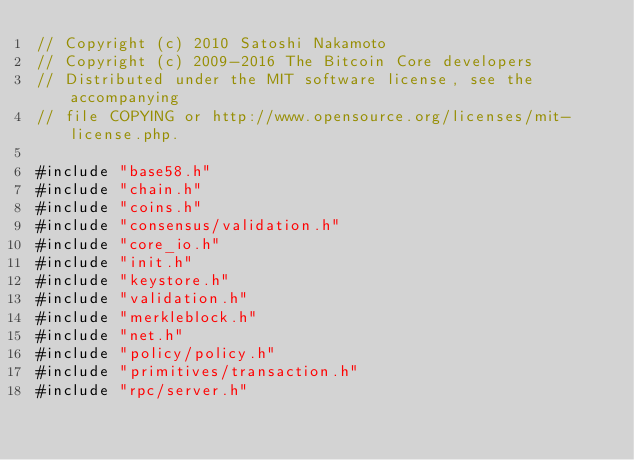Convert code to text. <code><loc_0><loc_0><loc_500><loc_500><_C++_>// Copyright (c) 2010 Satoshi Nakamoto
// Copyright (c) 2009-2016 The Bitcoin Core developers
// Distributed under the MIT software license, see the accompanying
// file COPYING or http://www.opensource.org/licenses/mit-license.php.

#include "base58.h"
#include "chain.h"
#include "coins.h"
#include "consensus/validation.h"
#include "core_io.h"
#include "init.h"
#include "keystore.h"
#include "validation.h"
#include "merkleblock.h"
#include "net.h"
#include "policy/policy.h"
#include "primitives/transaction.h"
#include "rpc/server.h"</code> 